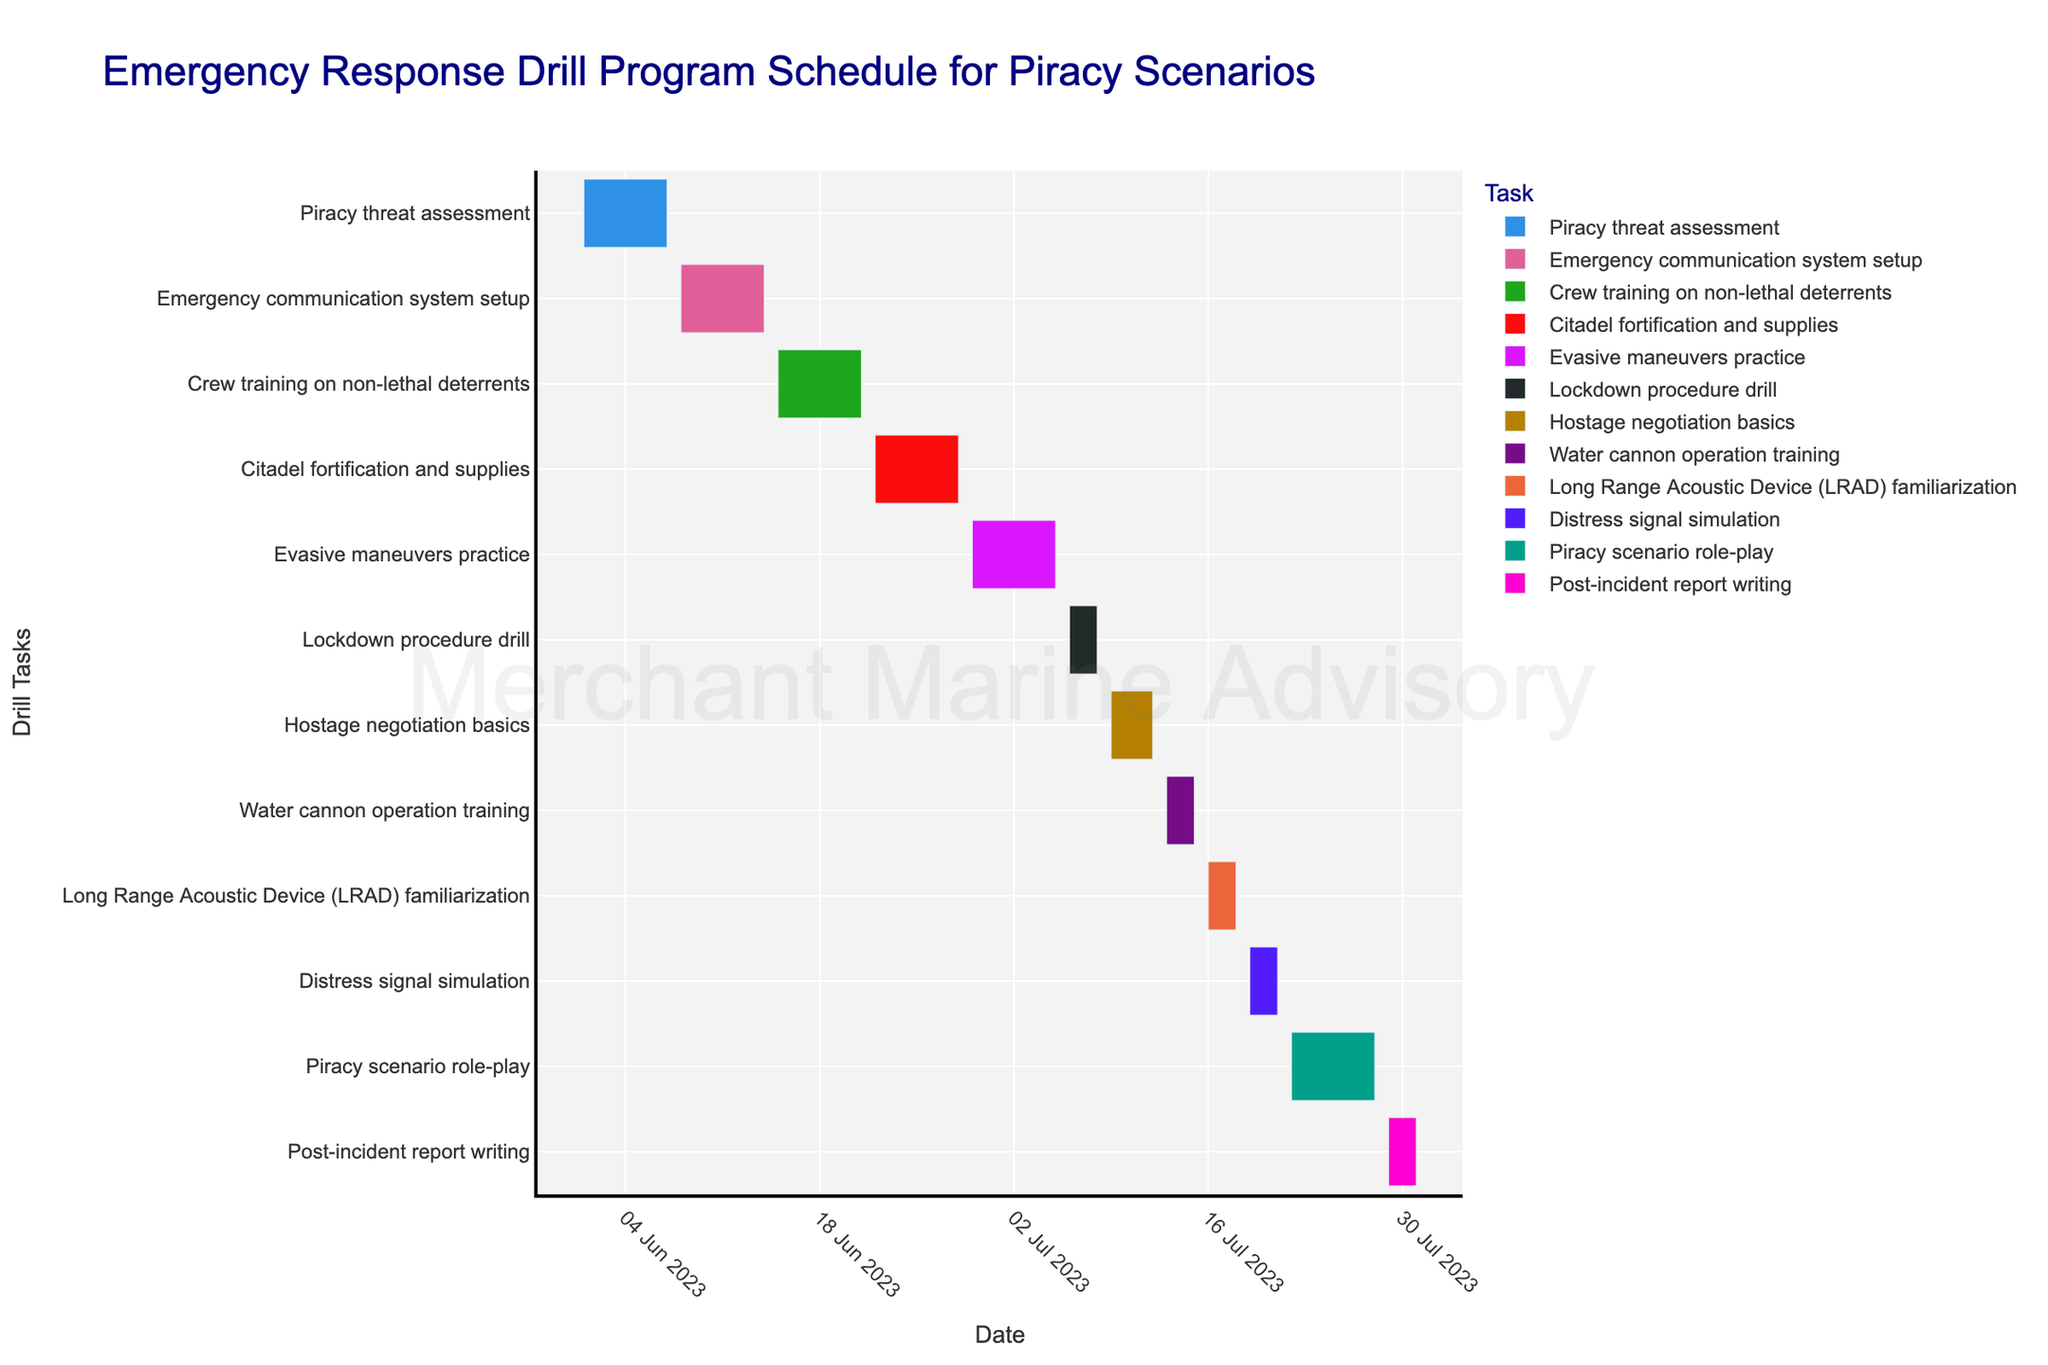What is the duration of the "Crew training on non-lethal deterrents" task? The duration of the "Crew training on non-lethal deterrents" can be calculated by taking the end date (2023-06-21) and subtracting the start date (2023-06-15). Thus, the duration is 21 - 15 = 6 days.
Answer: 6 days Which task runs the longest in this drill program? To identify the longest running task, we observe the duration bars in the Gantt chart and compare their lengths. By observing the chart, "Piracy scenario role-play" runs from 2023-07-22 to 2023-07-28 which is 7 days, making it the longest task.
Answer: Piracy scenario role-play How many tasks start in July 2023? By examining the task start dates in the Gantt chart and counting those which begin in July, we notice the tasks starting on 2023-07-01, 2023-07-06, 2023-07-09, 2023-07-13, 2023-07-16, 2023-07-19, and 2023-07-22. Thus, there are 7 tasks.
Answer: 7 Which task has the shortest duration, and what is it? The shortest duration can be identified by comparing the lengths of the bars. By visual inspection, "Water cannon operation training" and "Long Range Acoustic Device (LRAD) familiarization" both last from 2023-07-13 to 2023-07-15 and 2023-07-16 to 2023-07-18 respectively, each of 3 days, making them the shortest in duration.
Answer: Water cannon operation training, Long Range Acoustic Device (LRAD) familiarization Do any tasks overlap with "Citadel fortification and supplies"? To find overlap, we check if any tasks have start and end dates that intersect with "Citadel fortification and supplies" (2023-06-22 to 2023-06-28). No other tasks start or end during this period.
Answer: No tasks overlap What is the median duration of all tasks in the schedule? To find the median, first list all the durations: 6, 6, 6, 6, 7, 3, 4, 3, 3, 3, 7, 3. When ordered: 3, 3, 3, 3, 3, 4, 6, 6, 6, 6, 7, 7. Since there are 12 tasks, the median will be the average of the 6th and 7th values: (4+6)/2 = 5.
Answer: 5 days Which task immediately follows "Crew training on non-lethal deterrents"? By inspecting the end of "Crew training on non-lethal deterrents" (2023-06-21) and identifying the next starting task, we see "Citadel fortification and supplies" begins on 2023-06-22.
Answer: Citadel fortification and supplies Between "Evasive maneuvers practice" and "Distress signal simulation", which has the greater duration? The duration of "Evasive maneuvers practice" is from 2023-06-29 to 2023-07-05, totaling 7 days. "Distress signal simulation" runs from 2023-07-19 to 2023-07-21, totaling 3 days. Therefore, "Evasive maneuvers practice" has a greater duration.
Answer: Evasive maneuvers practice What is the overall timeframe covered by the entire drill program? The earliest start date in the chart is "Piracy threat assessment" on 2023-06-01, and the latest end date is "Post-incident report writing" on 2023-07-31. Thus, the overall timeframe spans from June 1st to July 31st.
Answer: June 1st to July 31st 